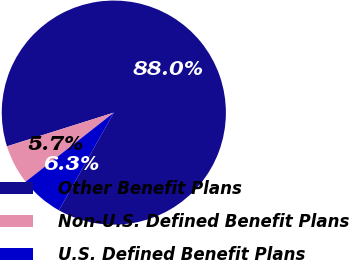<chart> <loc_0><loc_0><loc_500><loc_500><pie_chart><fcel>Other Benefit Plans<fcel>Non-U.S. Defined Benefit Plans<fcel>U.S. Defined Benefit Plans<nl><fcel>88.02%<fcel>5.71%<fcel>6.27%<nl></chart> 